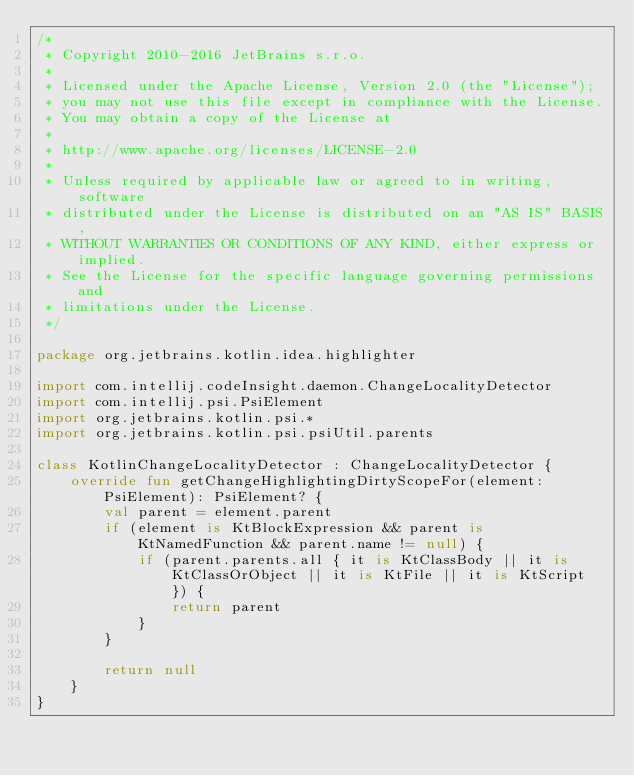Convert code to text. <code><loc_0><loc_0><loc_500><loc_500><_Kotlin_>/*
 * Copyright 2010-2016 JetBrains s.r.o.
 *
 * Licensed under the Apache License, Version 2.0 (the "License");
 * you may not use this file except in compliance with the License.
 * You may obtain a copy of the License at
 *
 * http://www.apache.org/licenses/LICENSE-2.0
 *
 * Unless required by applicable law or agreed to in writing, software
 * distributed under the License is distributed on an "AS IS" BASIS,
 * WITHOUT WARRANTIES OR CONDITIONS OF ANY KIND, either express or implied.
 * See the License for the specific language governing permissions and
 * limitations under the License.
 */

package org.jetbrains.kotlin.idea.highlighter

import com.intellij.codeInsight.daemon.ChangeLocalityDetector
import com.intellij.psi.PsiElement
import org.jetbrains.kotlin.psi.*
import org.jetbrains.kotlin.psi.psiUtil.parents

class KotlinChangeLocalityDetector : ChangeLocalityDetector {
    override fun getChangeHighlightingDirtyScopeFor(element: PsiElement): PsiElement? {
        val parent = element.parent
        if (element is KtBlockExpression && parent is KtNamedFunction && parent.name != null) {
            if (parent.parents.all { it is KtClassBody || it is KtClassOrObject || it is KtFile || it is KtScript }) {
                return parent
            }
        }

        return null
    }
}</code> 